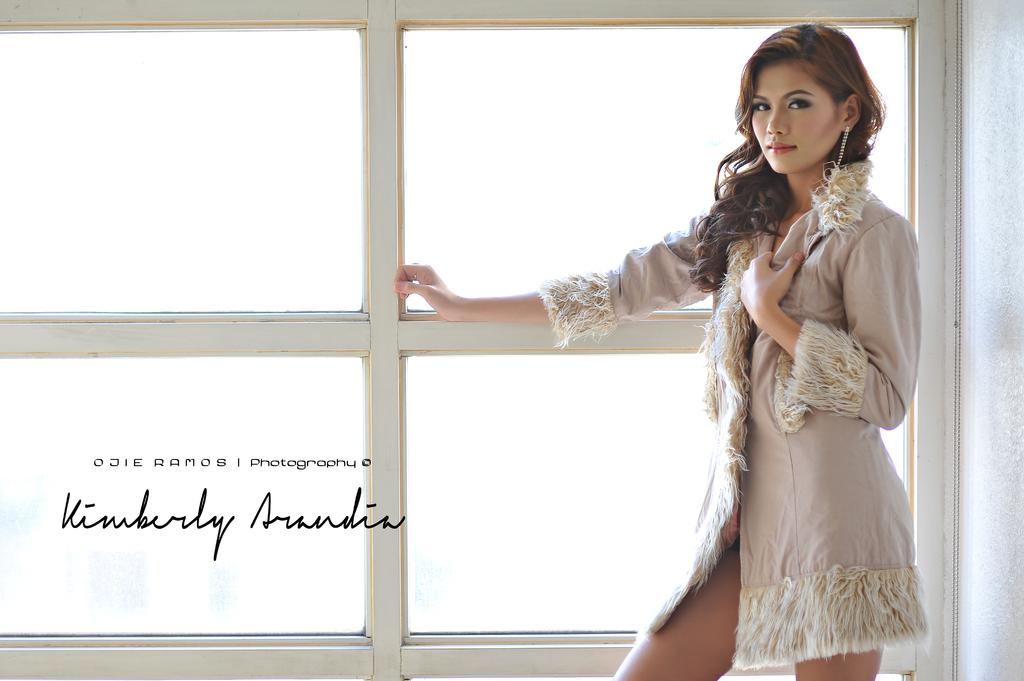Who is present in the image? There is a woman in the image. Where is the woman located in the image? The woman is standing in the right corner. What is the woman doing in the image? The woman has her hand placed on a glass window. Can you describe the position of the glass window in relation to the woman? The glass window is beside the woman. What else can be seen in the image? There is text or writing in the left bottom corner of the image. How many children are playing with the woman's hair in the image? There are no children present in the image, nor is there any indication of the woman's hair being played with. What type of prison can be seen in the background of the image? There is no prison present in the image; it features a woman standing beside a glass window with text or writing in the left bottom corner. 